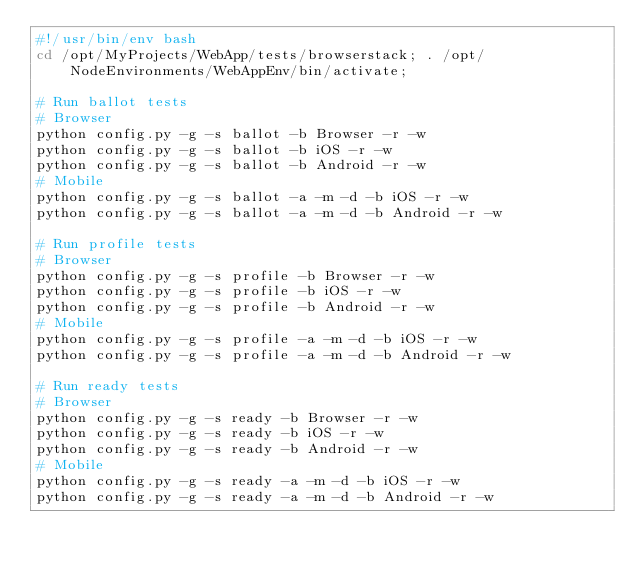<code> <loc_0><loc_0><loc_500><loc_500><_Bash_>#!/usr/bin/env bash
cd /opt/MyProjects/WebApp/tests/browserstack; . /opt/NodeEnvironments/WebAppEnv/bin/activate;

# Run ballot tests
# Browser
python config.py -g -s ballot -b Browser -r -w
python config.py -g -s ballot -b iOS -r -w
python config.py -g -s ballot -b Android -r -w
# Mobile
python config.py -g -s ballot -a -m -d -b iOS -r -w
python config.py -g -s ballot -a -m -d -b Android -r -w

# Run profile tests
# Browser
python config.py -g -s profile -b Browser -r -w
python config.py -g -s profile -b iOS -r -w
python config.py -g -s profile -b Android -r -w 
# Mobile
python config.py -g -s profile -a -m -d -b iOS -r -w
python config.py -g -s profile -a -m -d -b Android -r -w

# Run ready tests
# Browser
python config.py -g -s ready -b Browser -r -w
python config.py -g -s ready -b iOS -r -w
python config.py -g -s ready -b Android -r -w
# Mobile
python config.py -g -s ready -a -m -d -b iOS -r -w
python config.py -g -s ready -a -m -d -b Android -r -w
</code> 